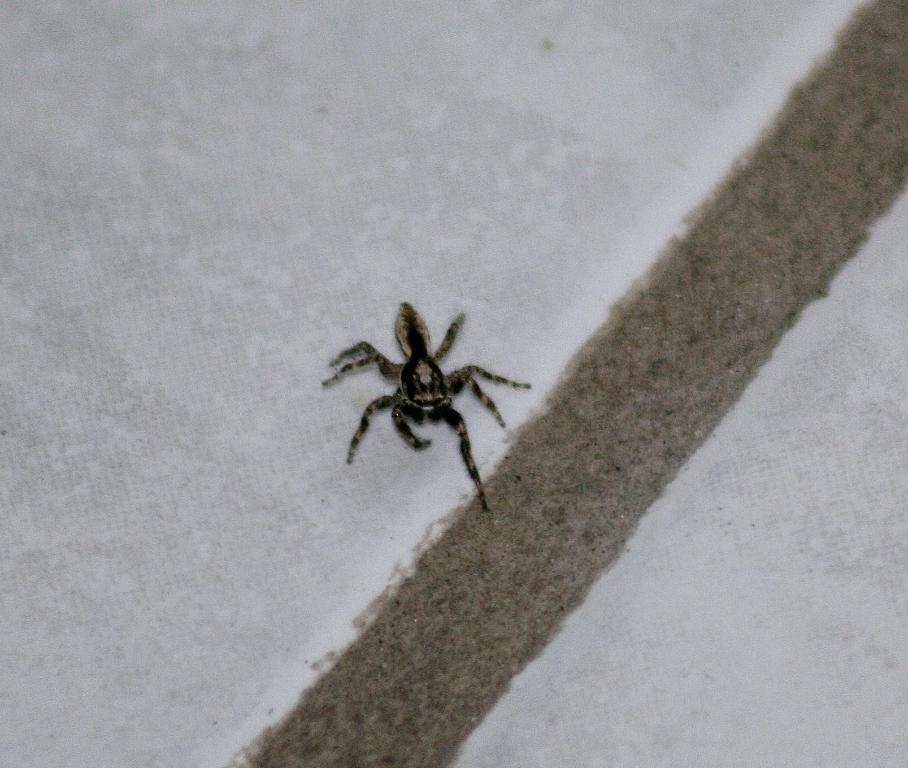Can you describe this image briefly? In the middle of the image there is a spider on a wall. 